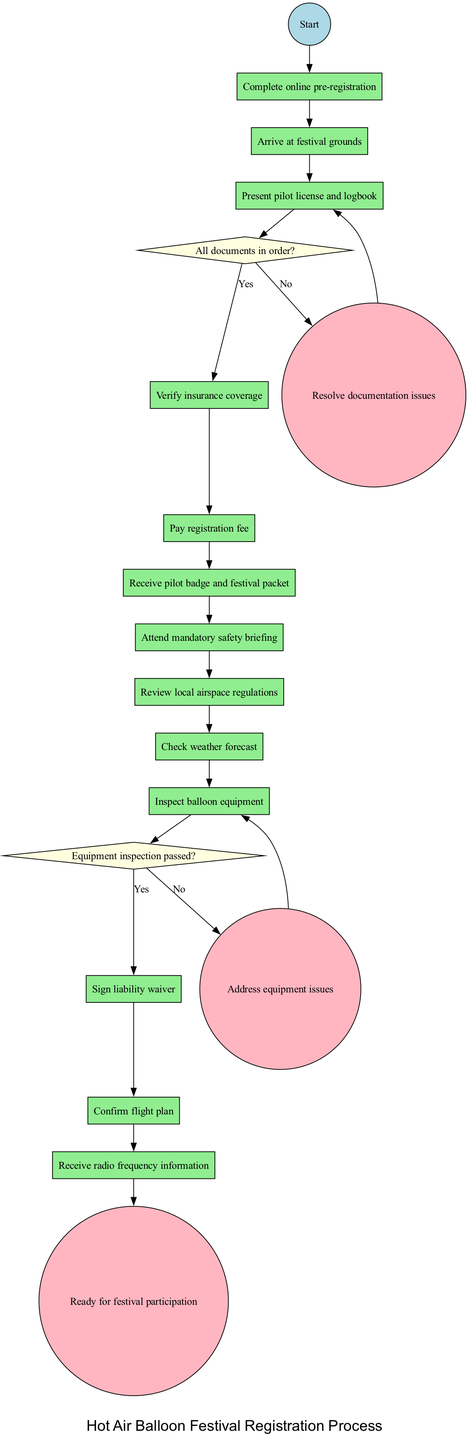What is the first activity in the procedure? The diagram shows the first activity following the 'Start' node, which is 'Complete online pre-registration'.
Answer: Complete online pre-registration What is the last node in the diagram? The diagram indicates that the final node leading to festival participation is labeled as 'Ready for festival participation'.
Answer: Ready for festival participation How many decision nodes are present in the diagram? By counting the nodes labeled with questions, we see that there are two decision nodes present in the diagram.
Answer: 2 What happens if the equipment inspection does not pass? The diagram specifies that if the equipment inspection does not pass, the next step is 'Address equipment issues'.
Answer: Address equipment issues What activity comes after paying the registration fee? The diagram shows that after paying the registration fee, participants receive 'pilot badge and festival packet'.
Answer: Receive pilot badge and festival packet What node follows the verification of insurance coverage? According to the diagram, the node that follows the verification of insurance coverage is 'Pay registration fee'.
Answer: Pay registration fee How do you resolve documentation issues? The diagram indicates that if documents are not in order, participants must 'Resolve documentation issues' before proceeding.
Answer: Resolve documentation issues What must a pilot do before attending the safety briefing? The diagram indicates several activities prior to the safety briefing; after receiving the pilot badge, they must 'Attend mandatory safety briefing'.
Answer: Attend mandatory safety briefing What do participants need to do after inspecting the balloon equipment? If the balloon equipment inspection is successful, as indicated by the diagram, the next step is to 'Sign liability waiver'.
Answer: Sign liability waiver 